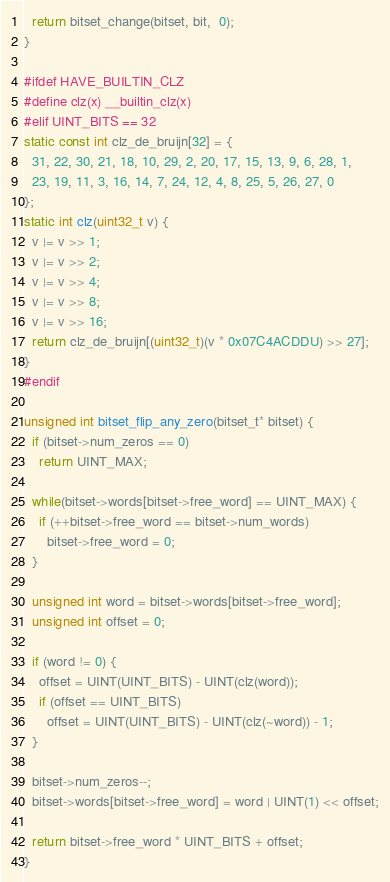Convert code to text. <code><loc_0><loc_0><loc_500><loc_500><_C_>  return bitset_change(bitset, bit,  0);
}

#ifdef HAVE_BUILTIN_CLZ
#define clz(x) __builtin_clz(x)
#elif UINT_BITS == 32
static const int clz_de_bruijn[32] = {
  31, 22, 30, 21, 18, 10, 29, 2, 20, 17, 15, 13, 9, 6, 28, 1,
  23, 19, 11, 3, 16, 14, 7, 24, 12, 4, 8, 25, 5, 26, 27, 0
};
static int clz(uint32_t v) {
  v |= v >> 1;
  v |= v >> 2;
  v |= v >> 4;
  v |= v >> 8;
  v |= v >> 16;
  return clz_de_bruijn[(uint32_t)(v * 0x07C4ACDDU) >> 27];
}
#endif

unsigned int bitset_flip_any_zero(bitset_t* bitset) {
  if (bitset->num_zeros == 0)
    return UINT_MAX;

  while(bitset->words[bitset->free_word] == UINT_MAX) {
    if (++bitset->free_word == bitset->num_words)
      bitset->free_word = 0;
  }

  unsigned int word = bitset->words[bitset->free_word];
  unsigned int offset = 0;

  if (word != 0) {
    offset = UINT(UINT_BITS) - UINT(clz(word));
    if (offset == UINT_BITS)
      offset = UINT(UINT_BITS) - UINT(clz(~word)) - 1;
  }

  bitset->num_zeros--;
  bitset->words[bitset->free_word] = word | UINT(1) << offset;

  return bitset->free_word * UINT_BITS + offset;
}
</code> 